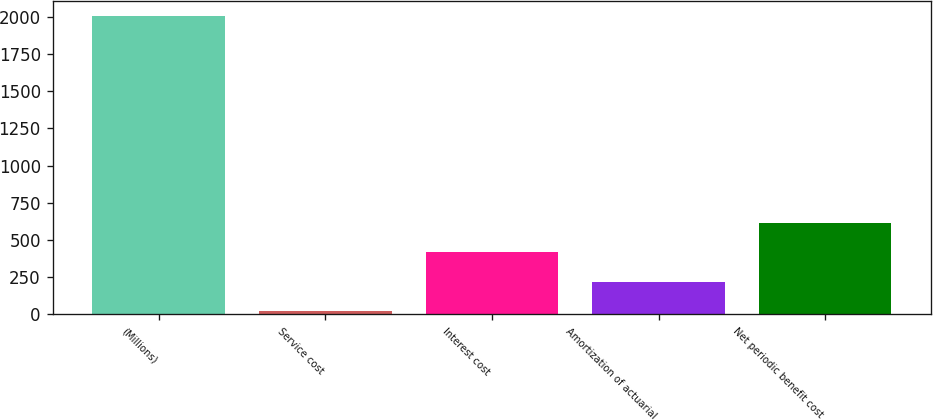Convert chart. <chart><loc_0><loc_0><loc_500><loc_500><bar_chart><fcel>(Millions)<fcel>Service cost<fcel>Interest cost<fcel>Amortization of actuarial<fcel>Net periodic benefit cost<nl><fcel>2004<fcel>22<fcel>418.4<fcel>220.2<fcel>616.6<nl></chart> 